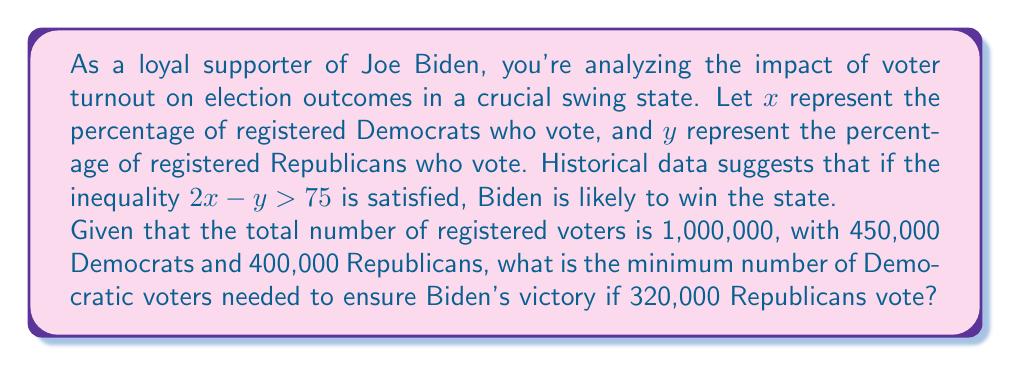Show me your answer to this math problem. Let's approach this step-by-step:

1) First, we need to calculate the percentage of Republicans voting:
   $y = \frac{320,000}{400,000} \times 100 = 80\%$

2) Now, we can use the inequality $2x - y > 75$ to find the minimum value of $x$:
   $2x - 80 > 75$
   $2x > 155$
   $x > 77.5$

3) This means the percentage of Democrats voting needs to be greater than 77.5%.

4) To find the actual number of Democratic voters needed, we multiply this percentage by the total number of registered Democrats:
   $\text{Minimum number of Democratic voters} = 450,000 \times 0.775 = 348,750$

5) However, since we can't have a fractional number of voters, we need to round up to the nearest whole number:
   $\text{Minimum number of Democratic voters} = 348,751$

This ensures that the inequality is strictly satisfied (>) rather than just equal to (=).
Answer: The minimum number of Democratic voters needed to ensure Biden's victory is 348,751. 